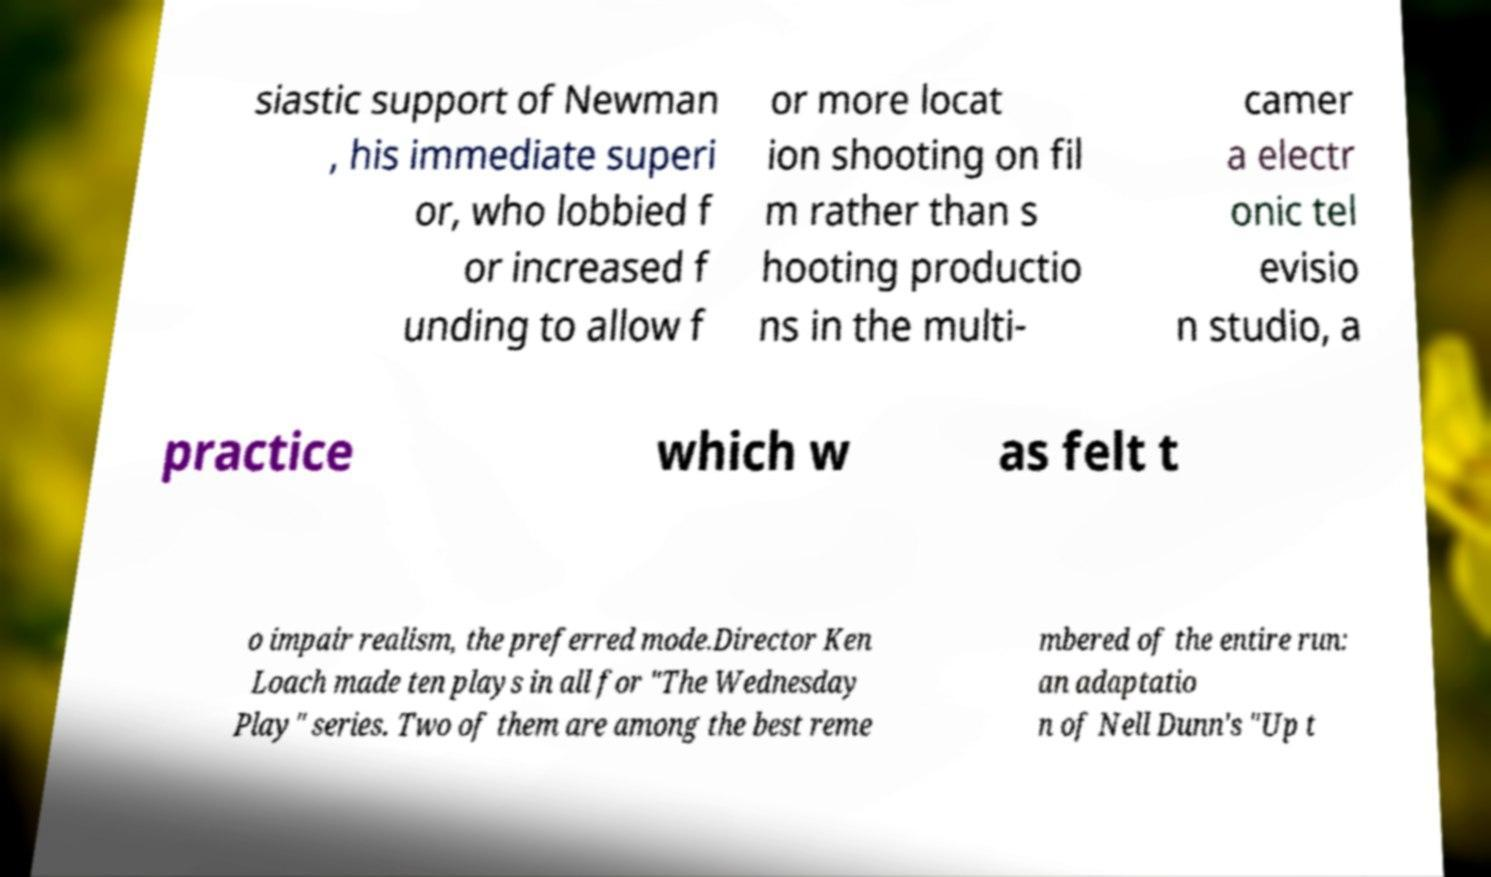Can you read and provide the text displayed in the image?This photo seems to have some interesting text. Can you extract and type it out for me? siastic support of Newman , his immediate superi or, who lobbied f or increased f unding to allow f or more locat ion shooting on fil m rather than s hooting productio ns in the multi- camer a electr onic tel evisio n studio, a practice which w as felt t o impair realism, the preferred mode.Director Ken Loach made ten plays in all for "The Wednesday Play" series. Two of them are among the best reme mbered of the entire run: an adaptatio n of Nell Dunn's "Up t 